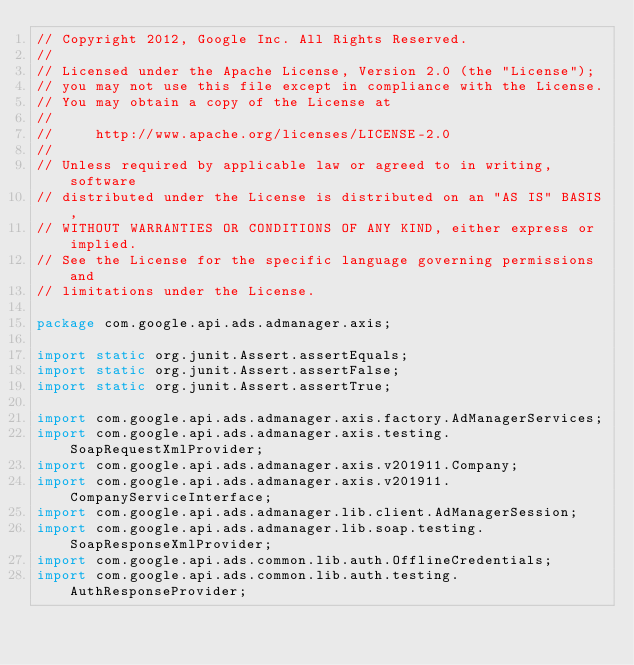<code> <loc_0><loc_0><loc_500><loc_500><_Java_>// Copyright 2012, Google Inc. All Rights Reserved.
//
// Licensed under the Apache License, Version 2.0 (the "License");
// you may not use this file except in compliance with the License.
// You may obtain a copy of the License at
//
//     http://www.apache.org/licenses/LICENSE-2.0
//
// Unless required by applicable law or agreed to in writing, software
// distributed under the License is distributed on an "AS IS" BASIS,
// WITHOUT WARRANTIES OR CONDITIONS OF ANY KIND, either express or implied.
// See the License for the specific language governing permissions and
// limitations under the License.

package com.google.api.ads.admanager.axis;

import static org.junit.Assert.assertEquals;
import static org.junit.Assert.assertFalse;
import static org.junit.Assert.assertTrue;

import com.google.api.ads.admanager.axis.factory.AdManagerServices;
import com.google.api.ads.admanager.axis.testing.SoapRequestXmlProvider;
import com.google.api.ads.admanager.axis.v201911.Company;
import com.google.api.ads.admanager.axis.v201911.CompanyServiceInterface;
import com.google.api.ads.admanager.lib.client.AdManagerSession;
import com.google.api.ads.admanager.lib.soap.testing.SoapResponseXmlProvider;
import com.google.api.ads.common.lib.auth.OfflineCredentials;
import com.google.api.ads.common.lib.auth.testing.AuthResponseProvider;</code> 